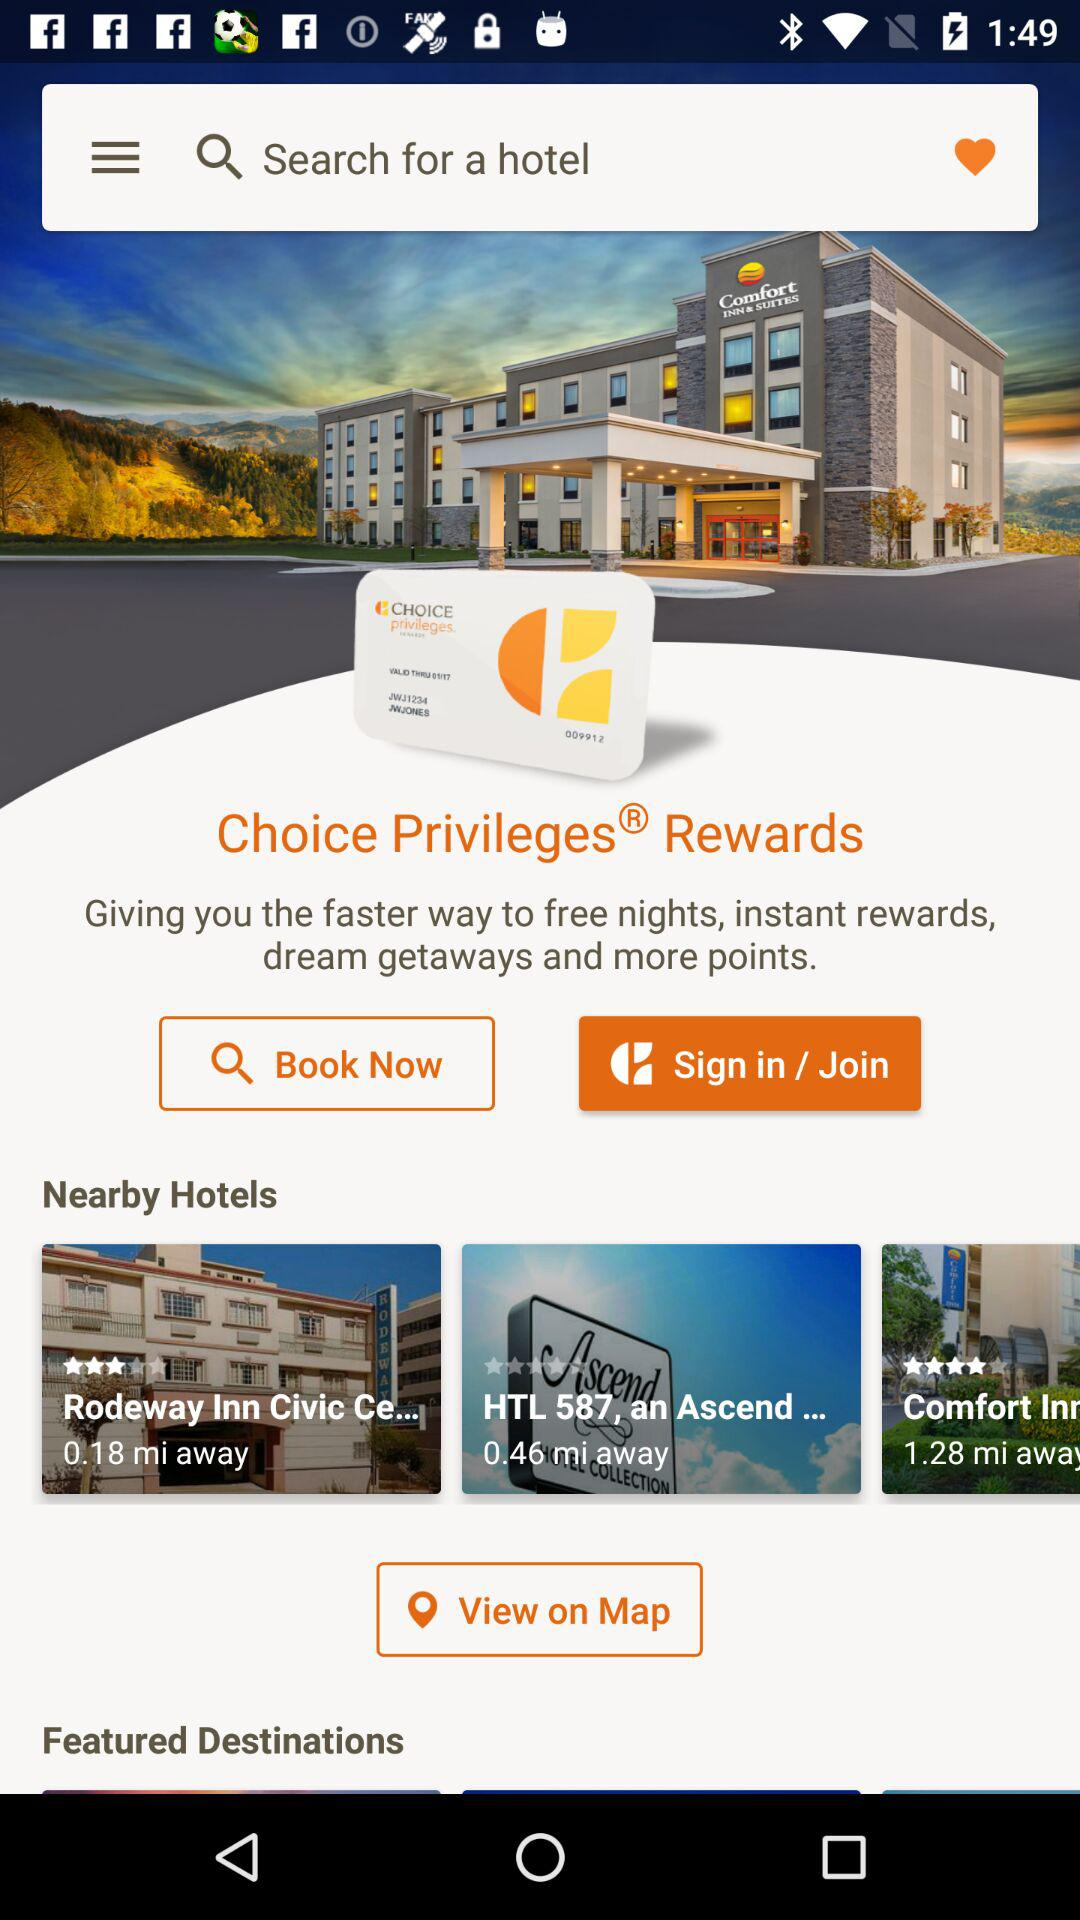How many miles away is the farthest hotel from the user?
Answer the question using a single word or phrase. 1.28 